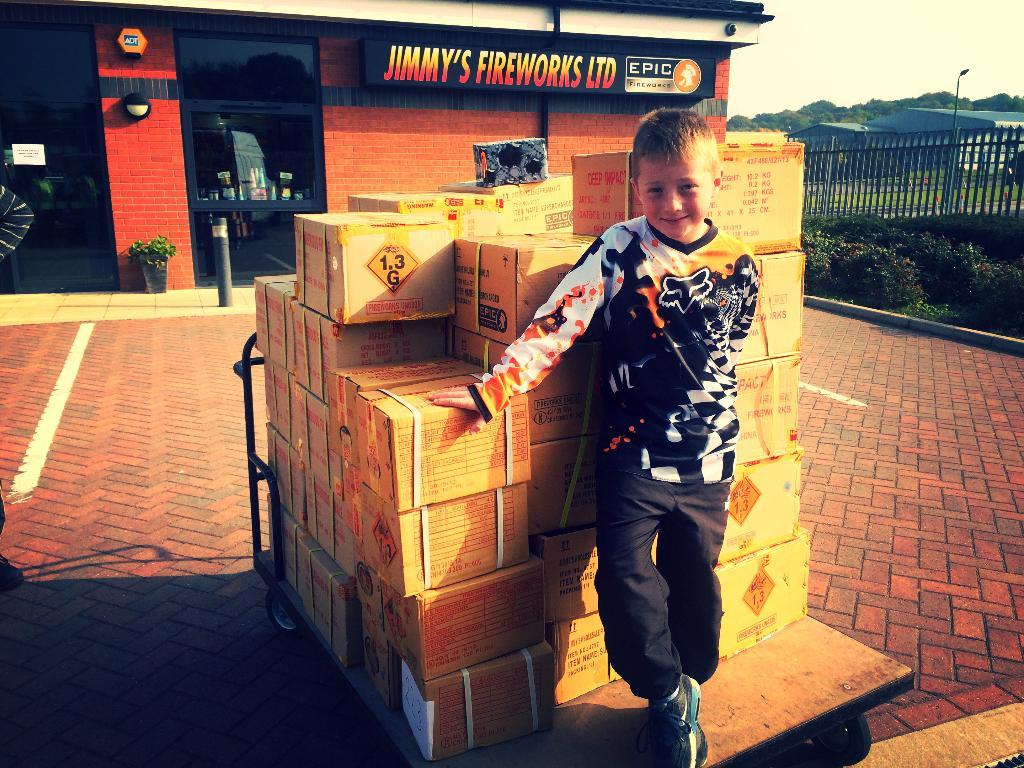<image>
Relay a brief, clear account of the picture shown. Young boy stands on a pallet of firework boxes at Jimmy's Fireworks LTD, Epic Fireworks store front. 